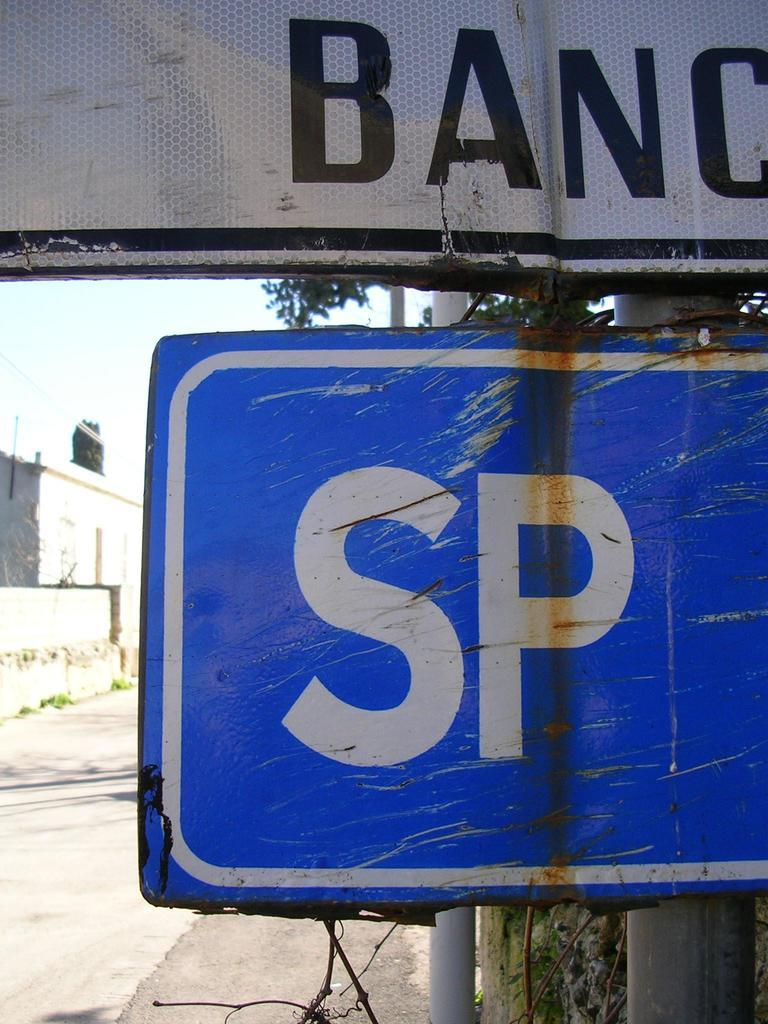<image>
Describe the image concisely. A battered blue and white sign with the letters SP on it. 